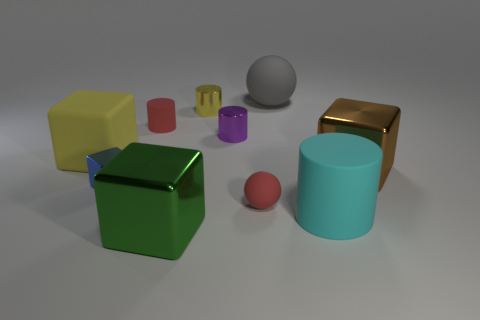How many other things are made of the same material as the yellow block?
Keep it short and to the point. 4. There is a big thing that is behind the tiny red matte thing that is behind the large metallic block that is behind the small blue shiny cube; what is its shape?
Your response must be concise. Sphere. Is the number of small red cylinders that are in front of the big cyan rubber cylinder less than the number of small blue shiny objects in front of the yellow metal object?
Keep it short and to the point. Yes. Is there a matte thing that has the same color as the big cylinder?
Offer a terse response. No. Does the red ball have the same material as the yellow object that is to the left of the green metallic thing?
Make the answer very short. Yes. There is a large shiny block that is on the left side of the gray rubber ball; are there any big green things in front of it?
Make the answer very short. No. What is the color of the large object that is both in front of the small blue object and behind the green cube?
Make the answer very short. Cyan. What size is the green block?
Give a very brief answer. Large. What number of rubber things are the same size as the red ball?
Offer a very short reply. 1. Are the yellow object in front of the tiny yellow cylinder and the sphere that is behind the yellow block made of the same material?
Ensure brevity in your answer.  Yes. 